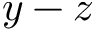Convert formula to latex. <formula><loc_0><loc_0><loc_500><loc_500>y - z</formula> 